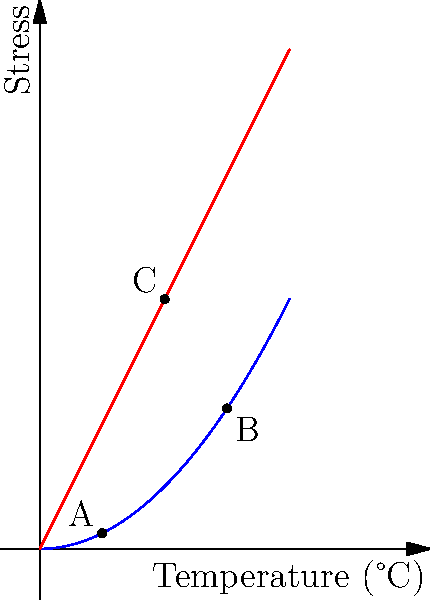In the graph above, which point represents the critical juncture where thermal stress overtakes mechanical stress during the pottery firing process in ancient kilns? To answer this question, we need to analyze the stress patterns shown in the graph:

1. The blue curve represents thermal stress, which increases non-linearly with temperature.
2. The red line represents mechanical stress, which increases linearly with temperature.
3. Point A is at a low temperature where thermal stress is less than mechanical stress.
4. Point C is where the thermal and mechanical stress lines intersect.
5. Point B is at a higher temperature where thermal stress exceeds mechanical stress.

The critical juncture occurs where thermal stress overtakes mechanical stress. This happens at the intersection point of the two lines, which is Point C.

At temperatures below Point C, mechanical stress dominates, potentially causing deformation but not cracking. Above Point C, thermal stress becomes the primary concern, increasing the risk of cracking or shattering during the firing process.

Understanding this transition point is crucial for ancient potters to control the firing process and produce high-quality ceramics without defects.
Answer: Point C 